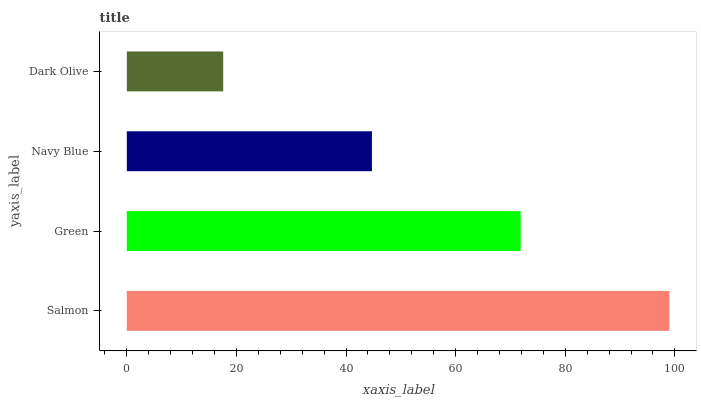Is Dark Olive the minimum?
Answer yes or no. Yes. Is Salmon the maximum?
Answer yes or no. Yes. Is Green the minimum?
Answer yes or no. No. Is Green the maximum?
Answer yes or no. No. Is Salmon greater than Green?
Answer yes or no. Yes. Is Green less than Salmon?
Answer yes or no. Yes. Is Green greater than Salmon?
Answer yes or no. No. Is Salmon less than Green?
Answer yes or no. No. Is Green the high median?
Answer yes or no. Yes. Is Navy Blue the low median?
Answer yes or no. Yes. Is Dark Olive the high median?
Answer yes or no. No. Is Dark Olive the low median?
Answer yes or no. No. 